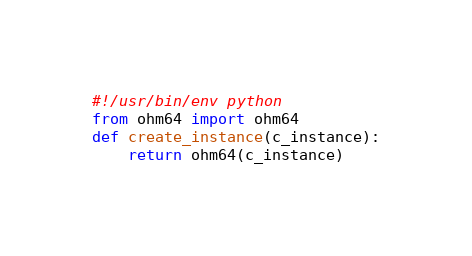<code> <loc_0><loc_0><loc_500><loc_500><_Python_>#!/usr/bin/env python
from ohm64 import ohm64
def create_instance(c_instance):
    return ohm64(c_instance)
</code> 